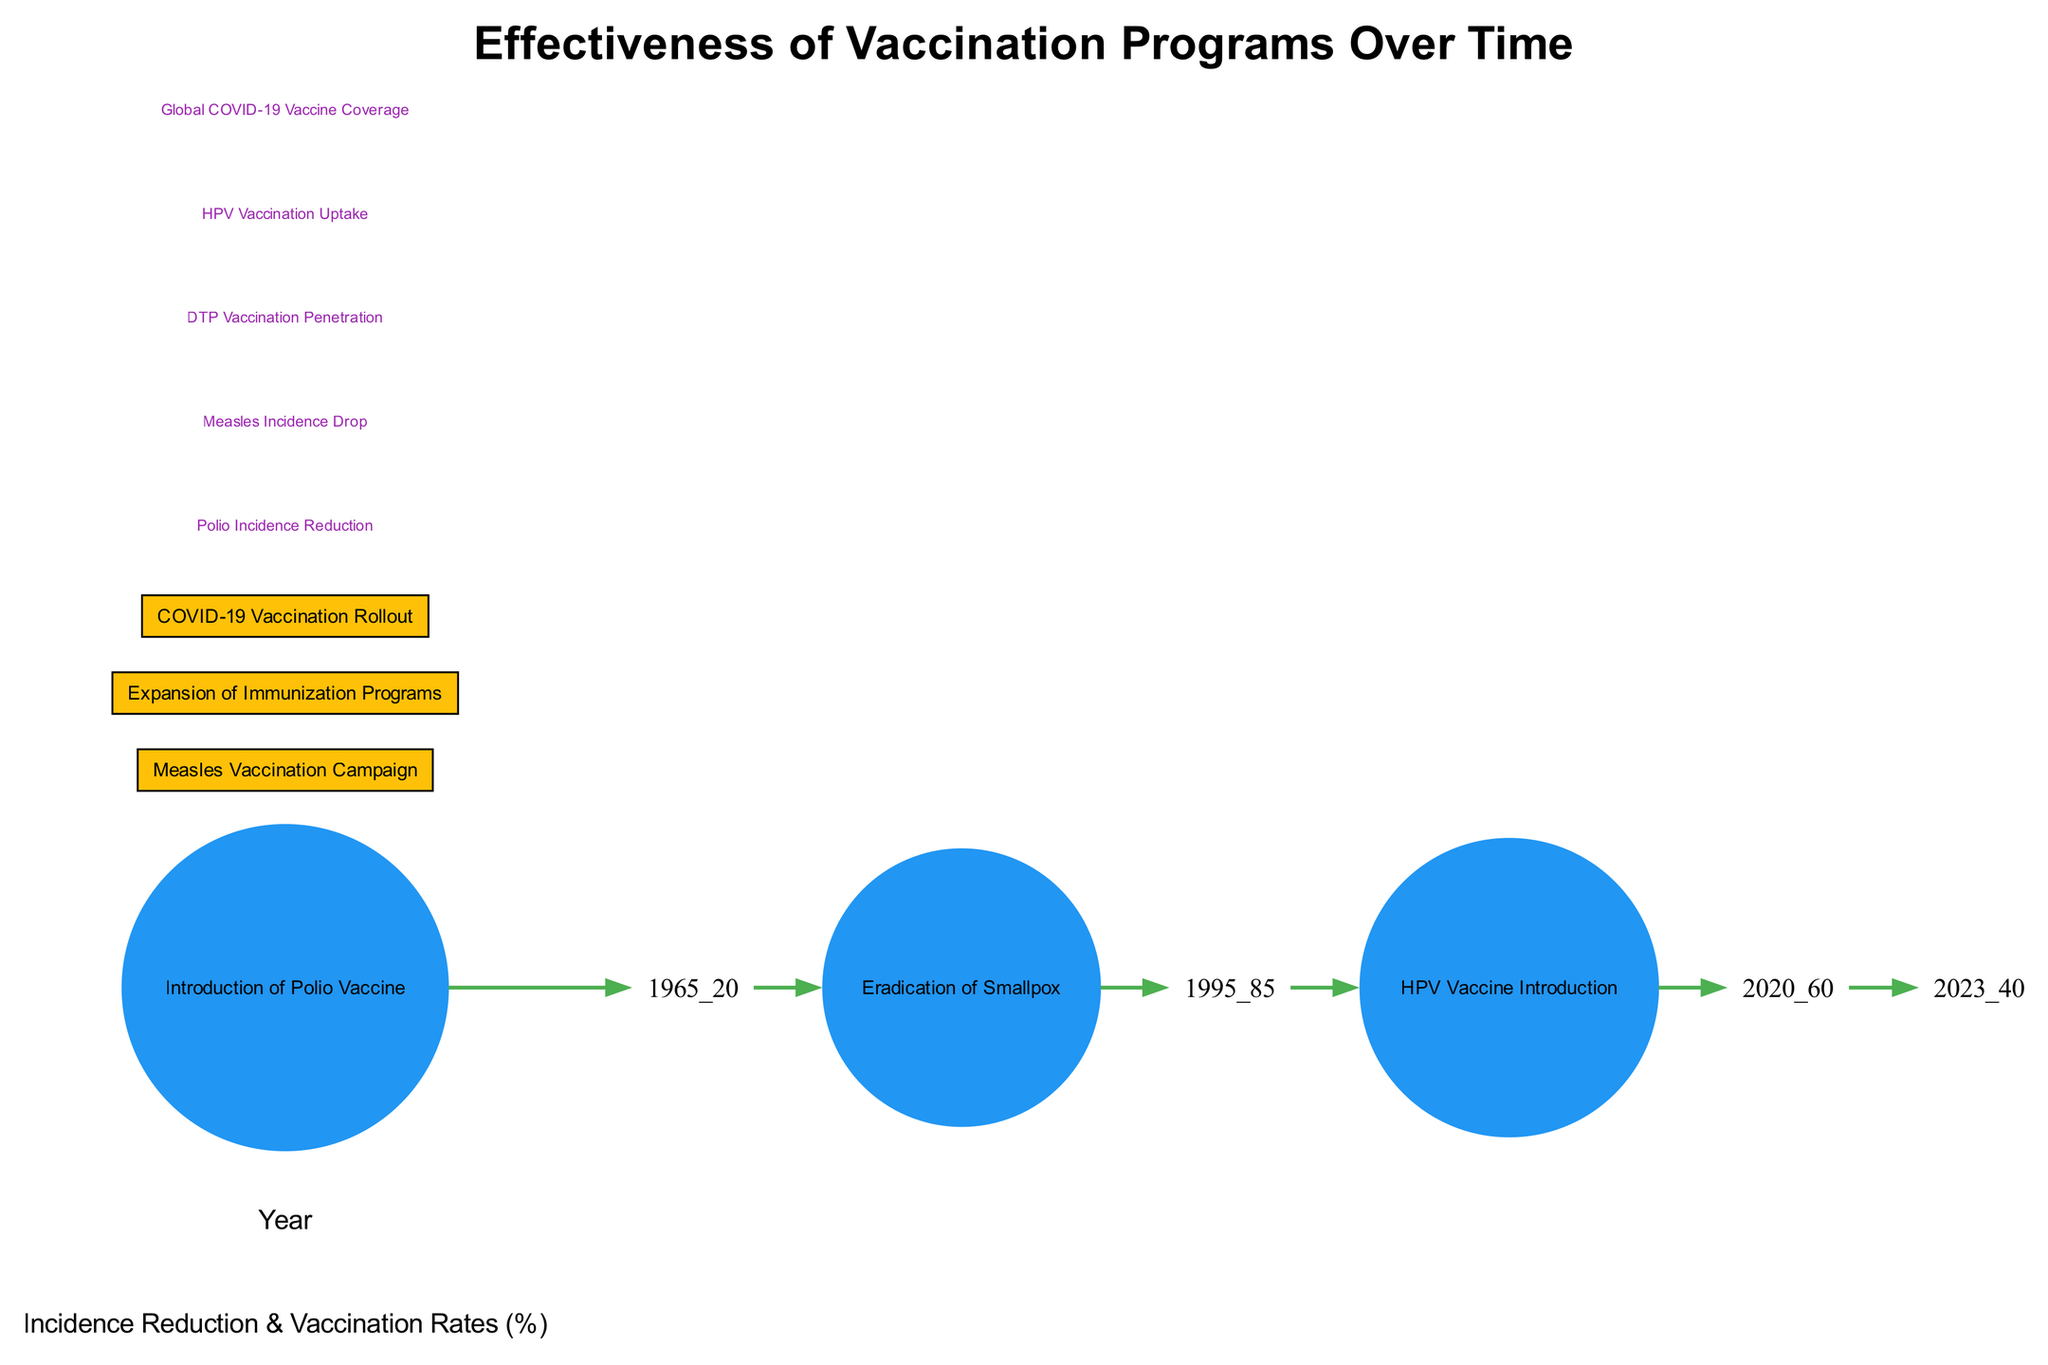What year did the Polio Vaccine get introduced? According to the diagram, the point labeled "Introduction of Polio Vaccine" is located at the year 1955.
Answer: 1955 What is the incidence reduction percentage associated with the eradication of Smallpox? The diagram shows a point marked "Eradication of Smallpox" at the year 1980 with an incidence reduction value of 100.
Answer: 100 How many major vaccination campaigns are highlighted in the diagram? The diagram highlights three major vaccination campaigns: the Measles Vaccination Campaign, Expansion of Immunization Programs, and COVID-19 Vaccination Rollout, making a total of three campaigns.
Answer: 3 What was the estimated vaccination uptake of HPV in 2015? A text node indicates "HPV Vaccination Uptake" in the year 2015 with a corresponding value of 60.
Answer: 60 Between which years did the Measles Vaccination Campaign take place? The diagram features a rectangular area labeled "Measles Vaccination Campaign" spanning from the year 1965 to the year 1974.
Answer: 1965 to 1974 What was the trend in incidence reduction from 1980 to 1995? From the year 1980, with an incidence reduction of 100, it decreases to 85 by 1995, indicating a downward trend from complete eradication.
Answer: Decrease What was the COVID-19 vaccine coverage in 2022? The diagram includes a text node labeled "Global COVID-19 Vaccine Coverage" in the year 2022, indicating a coverage percentage of 40.
Answer: 40 What was the incidence reduction at the start of the Measles Vaccination Campaign? The diagram indicates an incidence reduction of 20 in the year 1965, which is the starting point of the Measles Vaccination Campaign.
Answer: 20 What does the graph suggest about the relationship between vaccination rates and incidence reduction? The connections between nodes indicate that as vaccination rates increased throughout the years, incidence reduction generally followed the upward trend, showing a negative correlation.
Answer: Negative correlation 